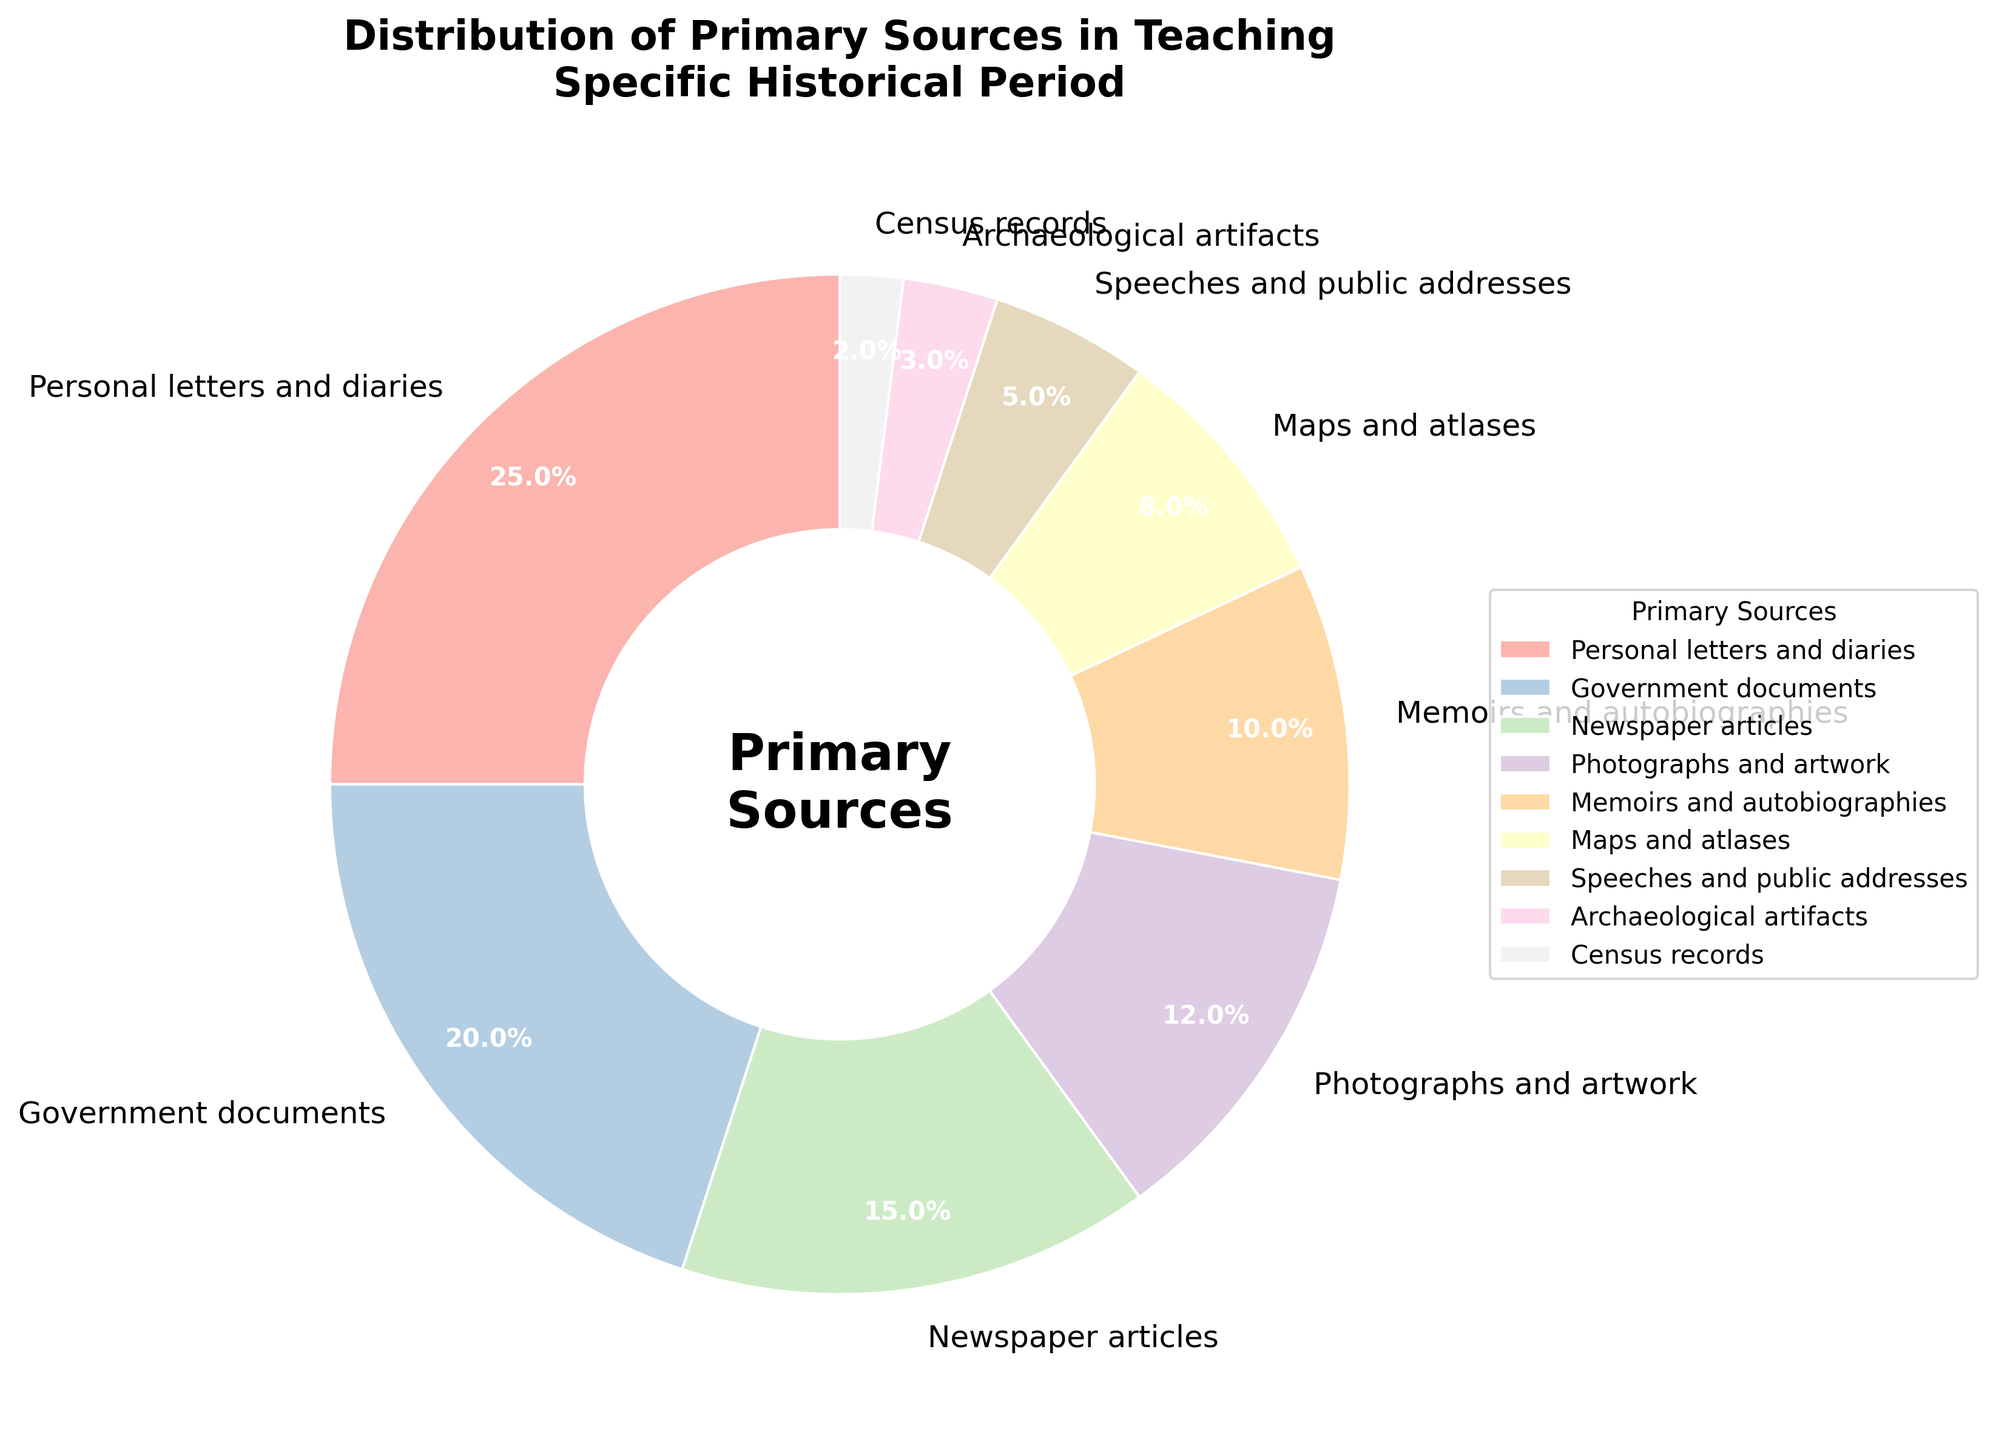what is the most common primary source used? The pie chart shows segments representing different primary sources with percentages. The largest segment corresponds to "Personal letters and diaries" with 25%.
Answer: Personal letters and diaries what two sources, when combined, account for 35% of the data? Adding percentages, "Photographs and artwork" (12%) and "Memoirs and autobiographies" (10%) together only give 22%, but "Newspaper articles" (15%) added to "Government documents" (20%) gives exactly 35%.
Answer: Government documents and Newspaper articles is the percentage of speeches and public addresses greater than maps and atlases? The chart shows "Speeches and public addresses" at 5% and "Maps and atlases" at 8%. 5% is less than 8%.
Answer: No how much larger is the percentage of government documents compared to census records? The pie chart assigns 20% to "Government documents" and 2% to "Census records". The difference is 20% - 2% = 18%.
Answer: 18% which primary source category is represented by the narrowest wedge in the chart? The pie chart depicts "Census records" as the smallest segment, assigned 2%.
Answer: Census records if the percentage of archaeological artifacts doubled, how would it compare to memoirs and autobiographies? Currently, "Archaeological artifacts" is at 3%. Doubling it gives 6%, which is still less than "Memoirs and autobiographies" at 10%.
Answer: Less which categories have a combined percentage less than that of personal letters and diaries? "Maps and atlases" (8%), "Speeches and public addresses" (5%), "Archaeological artifacts" (3%), and "Census records" (2%) together make 18%. This is less than "Personal letters and diaries" at 25%.
Answer: Maps and atlases, Speeches and public addresses, Archaeological artifacts, and Census records what is the average percentage of the three least common primary source categories? The least common categories are "Archaeological artifacts" (3%), "Census records" (2%), and "Speeches and public addresses" (5%). Their average is (3% + 2% + 5%) / 3 = 10% / 3 = approximately 3.33%.
Answer: approximately 3.33% how many categories contribute to more than 10% each? The pie chart shows the following categories above 10%: "Personal letters and diaries" (25%), "Government documents" (20%), "Newspaper articles" (15%), and "Photographs and artwork" (12%).
Answer: 4 